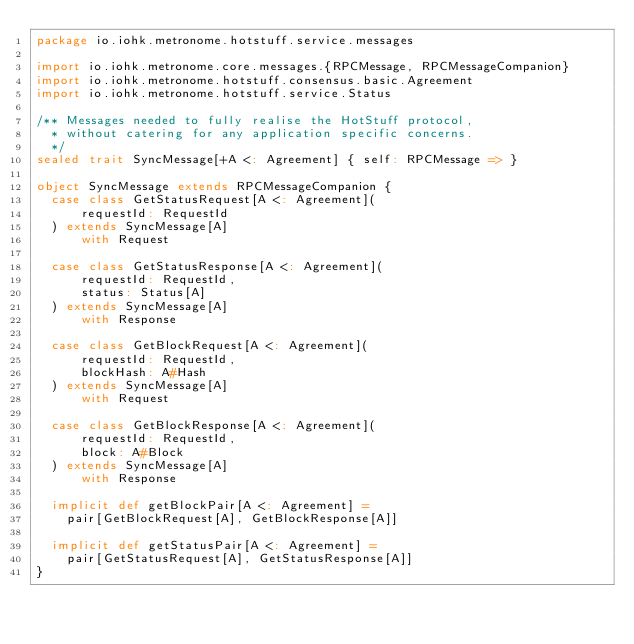Convert code to text. <code><loc_0><loc_0><loc_500><loc_500><_Scala_>package io.iohk.metronome.hotstuff.service.messages

import io.iohk.metronome.core.messages.{RPCMessage, RPCMessageCompanion}
import io.iohk.metronome.hotstuff.consensus.basic.Agreement
import io.iohk.metronome.hotstuff.service.Status

/** Messages needed to fully realise the HotStuff protocol,
  * without catering for any application specific concerns.
  */
sealed trait SyncMessage[+A <: Agreement] { self: RPCMessage => }

object SyncMessage extends RPCMessageCompanion {
  case class GetStatusRequest[A <: Agreement](
      requestId: RequestId
  ) extends SyncMessage[A]
      with Request

  case class GetStatusResponse[A <: Agreement](
      requestId: RequestId,
      status: Status[A]
  ) extends SyncMessage[A]
      with Response

  case class GetBlockRequest[A <: Agreement](
      requestId: RequestId,
      blockHash: A#Hash
  ) extends SyncMessage[A]
      with Request

  case class GetBlockResponse[A <: Agreement](
      requestId: RequestId,
      block: A#Block
  ) extends SyncMessage[A]
      with Response

  implicit def getBlockPair[A <: Agreement] =
    pair[GetBlockRequest[A], GetBlockResponse[A]]

  implicit def getStatusPair[A <: Agreement] =
    pair[GetStatusRequest[A], GetStatusResponse[A]]
}
</code> 